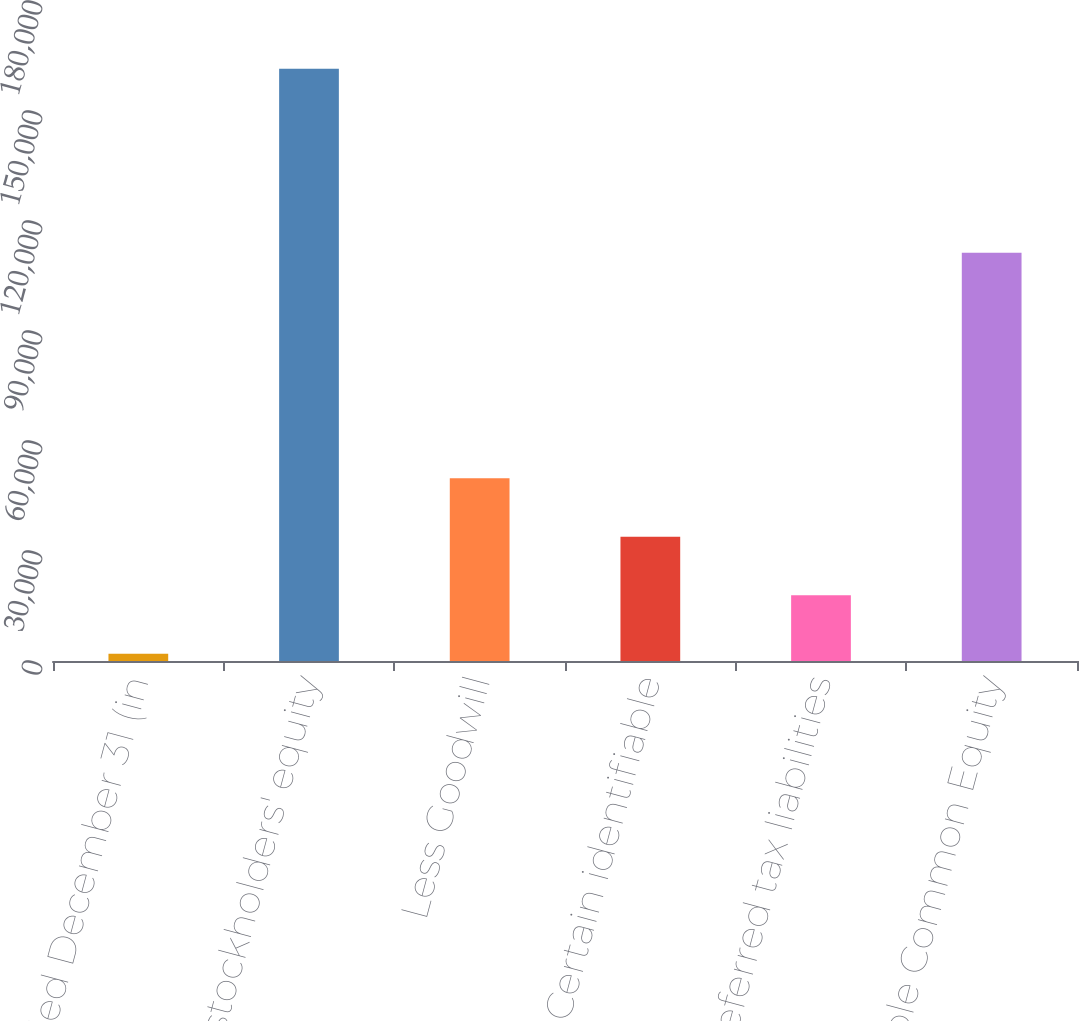<chart> <loc_0><loc_0><loc_500><loc_500><bar_chart><fcel>Year ended December 31 (in<fcel>Common stockholders' equity<fcel>Less Goodwill<fcel>Less Certain identifiable<fcel>Add Deferred tax liabilities<fcel>Tangible Common Equity<nl><fcel>2010<fcel>161520<fcel>49863<fcel>33912<fcel>17961<fcel>111311<nl></chart> 